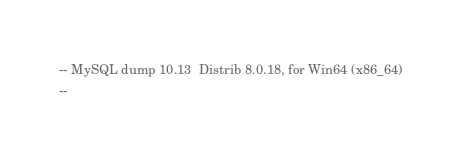<code> <loc_0><loc_0><loc_500><loc_500><_SQL_>-- MySQL dump 10.13  Distrib 8.0.18, for Win64 (x86_64)
--</code> 